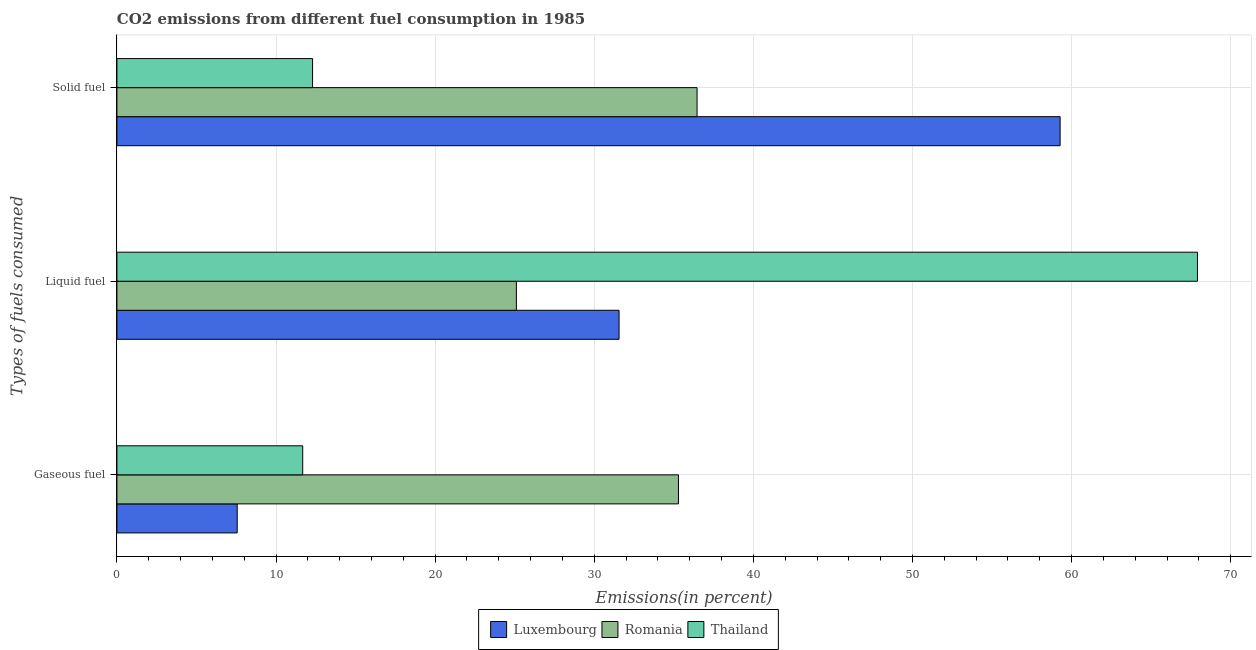How many different coloured bars are there?
Give a very brief answer. 3. How many groups of bars are there?
Your answer should be compact. 3. Are the number of bars per tick equal to the number of legend labels?
Your answer should be compact. Yes. Are the number of bars on each tick of the Y-axis equal?
Give a very brief answer. Yes. How many bars are there on the 1st tick from the top?
Your answer should be compact. 3. What is the label of the 2nd group of bars from the top?
Keep it short and to the point. Liquid fuel. What is the percentage of solid fuel emission in Luxembourg?
Make the answer very short. 59.28. Across all countries, what is the maximum percentage of liquid fuel emission?
Ensure brevity in your answer.  67.91. Across all countries, what is the minimum percentage of liquid fuel emission?
Make the answer very short. 25.11. In which country was the percentage of solid fuel emission maximum?
Provide a succinct answer. Luxembourg. In which country was the percentage of liquid fuel emission minimum?
Your answer should be very brief. Romania. What is the total percentage of solid fuel emission in the graph?
Provide a short and direct response. 108.04. What is the difference between the percentage of solid fuel emission in Thailand and that in Luxembourg?
Offer a very short reply. -46.98. What is the difference between the percentage of solid fuel emission in Thailand and the percentage of gaseous fuel emission in Romania?
Offer a very short reply. -23. What is the average percentage of solid fuel emission per country?
Your answer should be compact. 36.01. What is the difference between the percentage of solid fuel emission and percentage of liquid fuel emission in Luxembourg?
Offer a terse response. 27.72. What is the ratio of the percentage of solid fuel emission in Luxembourg to that in Romania?
Your answer should be compact. 1.63. Is the percentage of solid fuel emission in Romania less than that in Luxembourg?
Offer a terse response. Yes. What is the difference between the highest and the second highest percentage of solid fuel emission?
Offer a terse response. 22.82. What is the difference between the highest and the lowest percentage of solid fuel emission?
Offer a terse response. 46.98. In how many countries, is the percentage of solid fuel emission greater than the average percentage of solid fuel emission taken over all countries?
Make the answer very short. 2. Is the sum of the percentage of liquid fuel emission in Romania and Thailand greater than the maximum percentage of gaseous fuel emission across all countries?
Make the answer very short. Yes. What does the 3rd bar from the top in Gaseous fuel represents?
Provide a short and direct response. Luxembourg. What does the 3rd bar from the bottom in Solid fuel represents?
Offer a terse response. Thailand. What is the difference between two consecutive major ticks on the X-axis?
Make the answer very short. 10. Where does the legend appear in the graph?
Ensure brevity in your answer.  Bottom center. How many legend labels are there?
Your response must be concise. 3. How are the legend labels stacked?
Offer a very short reply. Horizontal. What is the title of the graph?
Make the answer very short. CO2 emissions from different fuel consumption in 1985. What is the label or title of the X-axis?
Your response must be concise. Emissions(in percent). What is the label or title of the Y-axis?
Your response must be concise. Types of fuels consumed. What is the Emissions(in percent) of Luxembourg in Gaseous fuel?
Your answer should be very brief. 7.56. What is the Emissions(in percent) of Romania in Gaseous fuel?
Offer a terse response. 35.29. What is the Emissions(in percent) of Thailand in Gaseous fuel?
Your answer should be compact. 11.68. What is the Emissions(in percent) in Luxembourg in Liquid fuel?
Give a very brief answer. 31.56. What is the Emissions(in percent) of Romania in Liquid fuel?
Your answer should be very brief. 25.11. What is the Emissions(in percent) of Thailand in Liquid fuel?
Ensure brevity in your answer.  67.91. What is the Emissions(in percent) of Luxembourg in Solid fuel?
Give a very brief answer. 59.28. What is the Emissions(in percent) in Romania in Solid fuel?
Make the answer very short. 36.46. What is the Emissions(in percent) of Thailand in Solid fuel?
Ensure brevity in your answer.  12.3. Across all Types of fuels consumed, what is the maximum Emissions(in percent) of Luxembourg?
Your response must be concise. 59.28. Across all Types of fuels consumed, what is the maximum Emissions(in percent) of Romania?
Your response must be concise. 36.46. Across all Types of fuels consumed, what is the maximum Emissions(in percent) of Thailand?
Ensure brevity in your answer.  67.91. Across all Types of fuels consumed, what is the minimum Emissions(in percent) in Luxembourg?
Ensure brevity in your answer.  7.56. Across all Types of fuels consumed, what is the minimum Emissions(in percent) of Romania?
Offer a terse response. 25.11. Across all Types of fuels consumed, what is the minimum Emissions(in percent) in Thailand?
Give a very brief answer. 11.68. What is the total Emissions(in percent) of Luxembourg in the graph?
Provide a short and direct response. 98.4. What is the total Emissions(in percent) in Romania in the graph?
Provide a short and direct response. 96.86. What is the total Emissions(in percent) of Thailand in the graph?
Your response must be concise. 91.89. What is the difference between the Emissions(in percent) in Romania in Gaseous fuel and that in Liquid fuel?
Keep it short and to the point. 10.19. What is the difference between the Emissions(in percent) of Thailand in Gaseous fuel and that in Liquid fuel?
Your response must be concise. -56.23. What is the difference between the Emissions(in percent) in Luxembourg in Gaseous fuel and that in Solid fuel?
Provide a short and direct response. -51.72. What is the difference between the Emissions(in percent) of Romania in Gaseous fuel and that in Solid fuel?
Offer a terse response. -1.17. What is the difference between the Emissions(in percent) of Thailand in Gaseous fuel and that in Solid fuel?
Offer a very short reply. -0.62. What is the difference between the Emissions(in percent) in Luxembourg in Liquid fuel and that in Solid fuel?
Your response must be concise. -27.72. What is the difference between the Emissions(in percent) of Romania in Liquid fuel and that in Solid fuel?
Offer a very short reply. -11.36. What is the difference between the Emissions(in percent) of Thailand in Liquid fuel and that in Solid fuel?
Provide a succinct answer. 55.62. What is the difference between the Emissions(in percent) in Luxembourg in Gaseous fuel and the Emissions(in percent) in Romania in Liquid fuel?
Your answer should be very brief. -17.55. What is the difference between the Emissions(in percent) of Luxembourg in Gaseous fuel and the Emissions(in percent) of Thailand in Liquid fuel?
Provide a succinct answer. -60.35. What is the difference between the Emissions(in percent) of Romania in Gaseous fuel and the Emissions(in percent) of Thailand in Liquid fuel?
Your answer should be compact. -32.62. What is the difference between the Emissions(in percent) in Luxembourg in Gaseous fuel and the Emissions(in percent) in Romania in Solid fuel?
Offer a very short reply. -28.9. What is the difference between the Emissions(in percent) in Luxembourg in Gaseous fuel and the Emissions(in percent) in Thailand in Solid fuel?
Provide a short and direct response. -4.74. What is the difference between the Emissions(in percent) of Romania in Gaseous fuel and the Emissions(in percent) of Thailand in Solid fuel?
Your answer should be compact. 23. What is the difference between the Emissions(in percent) in Luxembourg in Liquid fuel and the Emissions(in percent) in Romania in Solid fuel?
Make the answer very short. -4.9. What is the difference between the Emissions(in percent) in Luxembourg in Liquid fuel and the Emissions(in percent) in Thailand in Solid fuel?
Offer a very short reply. 19.26. What is the difference between the Emissions(in percent) in Romania in Liquid fuel and the Emissions(in percent) in Thailand in Solid fuel?
Your answer should be compact. 12.81. What is the average Emissions(in percent) of Luxembourg per Types of fuels consumed?
Ensure brevity in your answer.  32.8. What is the average Emissions(in percent) of Romania per Types of fuels consumed?
Keep it short and to the point. 32.29. What is the average Emissions(in percent) of Thailand per Types of fuels consumed?
Give a very brief answer. 30.63. What is the difference between the Emissions(in percent) in Luxembourg and Emissions(in percent) in Romania in Gaseous fuel?
Offer a terse response. -27.73. What is the difference between the Emissions(in percent) of Luxembourg and Emissions(in percent) of Thailand in Gaseous fuel?
Keep it short and to the point. -4.12. What is the difference between the Emissions(in percent) in Romania and Emissions(in percent) in Thailand in Gaseous fuel?
Your answer should be compact. 23.61. What is the difference between the Emissions(in percent) of Luxembourg and Emissions(in percent) of Romania in Liquid fuel?
Your answer should be compact. 6.45. What is the difference between the Emissions(in percent) of Luxembourg and Emissions(in percent) of Thailand in Liquid fuel?
Ensure brevity in your answer.  -36.35. What is the difference between the Emissions(in percent) of Romania and Emissions(in percent) of Thailand in Liquid fuel?
Keep it short and to the point. -42.81. What is the difference between the Emissions(in percent) of Luxembourg and Emissions(in percent) of Romania in Solid fuel?
Provide a succinct answer. 22.82. What is the difference between the Emissions(in percent) in Luxembourg and Emissions(in percent) in Thailand in Solid fuel?
Your answer should be very brief. 46.98. What is the difference between the Emissions(in percent) in Romania and Emissions(in percent) in Thailand in Solid fuel?
Your response must be concise. 24.17. What is the ratio of the Emissions(in percent) in Luxembourg in Gaseous fuel to that in Liquid fuel?
Your response must be concise. 0.24. What is the ratio of the Emissions(in percent) in Romania in Gaseous fuel to that in Liquid fuel?
Keep it short and to the point. 1.41. What is the ratio of the Emissions(in percent) in Thailand in Gaseous fuel to that in Liquid fuel?
Provide a short and direct response. 0.17. What is the ratio of the Emissions(in percent) in Luxembourg in Gaseous fuel to that in Solid fuel?
Make the answer very short. 0.13. What is the ratio of the Emissions(in percent) of Romania in Gaseous fuel to that in Solid fuel?
Your response must be concise. 0.97. What is the ratio of the Emissions(in percent) of Thailand in Gaseous fuel to that in Solid fuel?
Your answer should be compact. 0.95. What is the ratio of the Emissions(in percent) in Luxembourg in Liquid fuel to that in Solid fuel?
Ensure brevity in your answer.  0.53. What is the ratio of the Emissions(in percent) in Romania in Liquid fuel to that in Solid fuel?
Your answer should be very brief. 0.69. What is the ratio of the Emissions(in percent) of Thailand in Liquid fuel to that in Solid fuel?
Provide a succinct answer. 5.52. What is the difference between the highest and the second highest Emissions(in percent) in Luxembourg?
Keep it short and to the point. 27.72. What is the difference between the highest and the second highest Emissions(in percent) in Romania?
Offer a very short reply. 1.17. What is the difference between the highest and the second highest Emissions(in percent) of Thailand?
Provide a succinct answer. 55.62. What is the difference between the highest and the lowest Emissions(in percent) in Luxembourg?
Make the answer very short. 51.72. What is the difference between the highest and the lowest Emissions(in percent) of Romania?
Provide a succinct answer. 11.36. What is the difference between the highest and the lowest Emissions(in percent) of Thailand?
Keep it short and to the point. 56.23. 